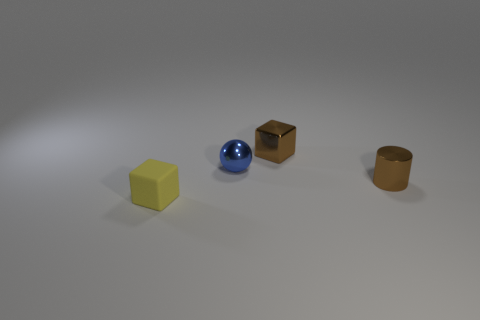Is there anything else that is made of the same material as the yellow object?
Ensure brevity in your answer.  No. Is the small brown cylinder made of the same material as the tiny block that is in front of the small metallic cube?
Keep it short and to the point. No. Are there the same number of tiny metallic cylinders that are in front of the metal cylinder and tiny yellow rubber objects?
Your answer should be very brief. No. The tiny metal thing that is behind the tiny ball is what color?
Keep it short and to the point. Brown. What number of other objects are the same color as the rubber cube?
Ensure brevity in your answer.  0. Is there any other thing that has the same size as the brown shiny cylinder?
Provide a short and direct response. Yes. There is a shiny thing behind the blue sphere; does it have the same size as the brown cylinder?
Make the answer very short. Yes. There is a block that is left of the shiny cube; what is it made of?
Ensure brevity in your answer.  Rubber. Is there anything else that is the same shape as the blue object?
Make the answer very short. No. What number of metal objects are small green cylinders or yellow objects?
Offer a very short reply. 0. 